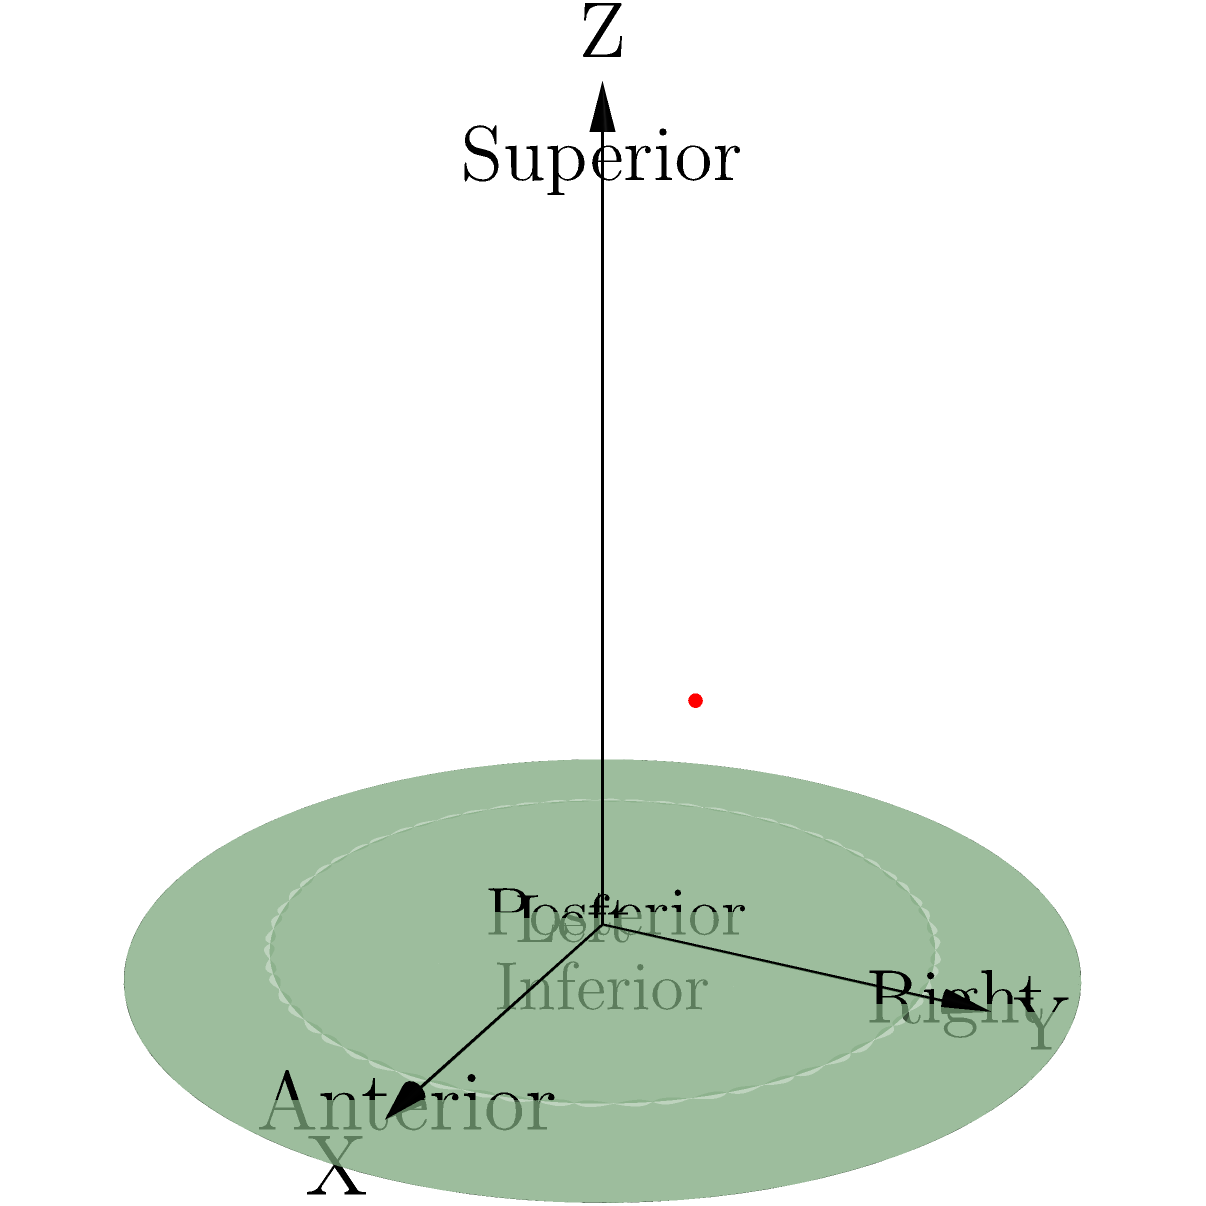Using the standardized brain atlas coordinate system shown in the image, identify the approximate location of the brain lesion (red dot). Express your answer as a set of coordinates (X, Y, Z), where each coordinate is rounded to the nearest tenth. To determine the location of the brain lesion using the standardized brain atlas coordinate system, we need to follow these steps:

1. Understand the coordinate system:
   - The X-axis represents the left-right direction (increasing from left to right)
   - The Y-axis represents the posterior-anterior direction (increasing from back to front)
   - The Z-axis represents the inferior-superior direction (increasing from bottom to top)

2. Estimate the position of the red dot along each axis:
   - X-axis: The dot appears to be about 70% of the way from left to right
   - Y-axis: The dot seems to be approximately 60% of the way from posterior to anterior
   - Z-axis: The dot looks to be around 50% of the way from inferior to superior

3. Convert these estimates to decimal coordinates:
   - X ≈ 0.7
   - Y ≈ 0.6
   - Z ≈ 0.5

4. Round each coordinate to the nearest tenth (which they already are in this case)

5. Express the coordinates as an ordered triple (X, Y, Z)

Therefore, the approximate location of the brain lesion in the standardized brain atlas coordinate system is (0.7, 0.6, 0.5).
Answer: (0.7, 0.6, 0.5) 